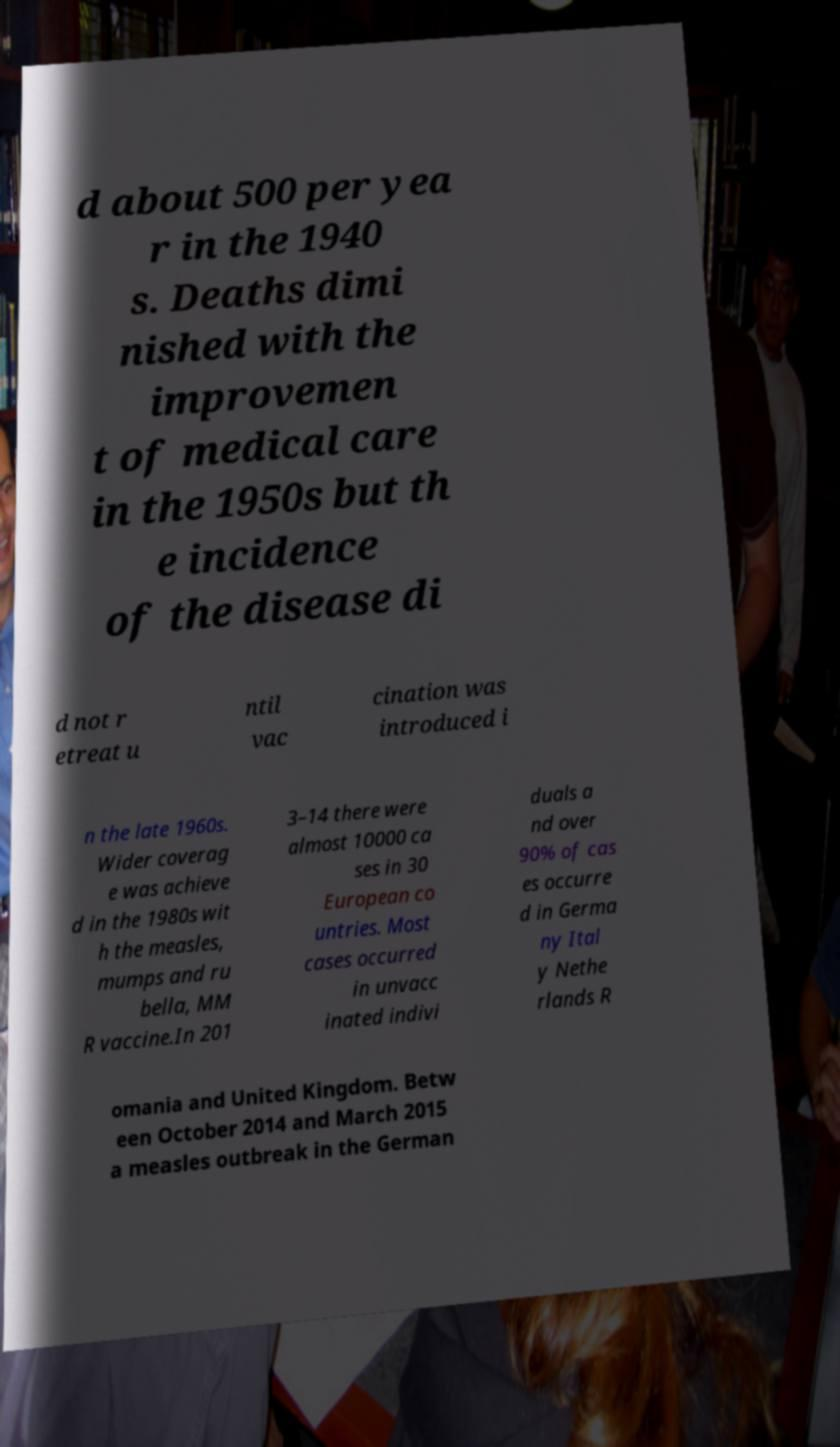Could you assist in decoding the text presented in this image and type it out clearly? d about 500 per yea r in the 1940 s. Deaths dimi nished with the improvemen t of medical care in the 1950s but th e incidence of the disease di d not r etreat u ntil vac cination was introduced i n the late 1960s. Wider coverag e was achieve d in the 1980s wit h the measles, mumps and ru bella, MM R vaccine.In 201 3–14 there were almost 10000 ca ses in 30 European co untries. Most cases occurred in unvacc inated indivi duals a nd over 90% of cas es occurre d in Germa ny Ital y Nethe rlands R omania and United Kingdom. Betw een October 2014 and March 2015 a measles outbreak in the German 